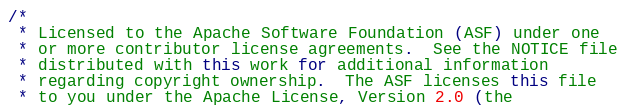Convert code to text. <code><loc_0><loc_0><loc_500><loc_500><_Java_>/*
 * Licensed to the Apache Software Foundation (ASF) under one
 * or more contributor license agreements.  See the NOTICE file
 * distributed with this work for additional information
 * regarding copyright ownership.  The ASF licenses this file
 * to you under the Apache License, Version 2.0 (the</code> 